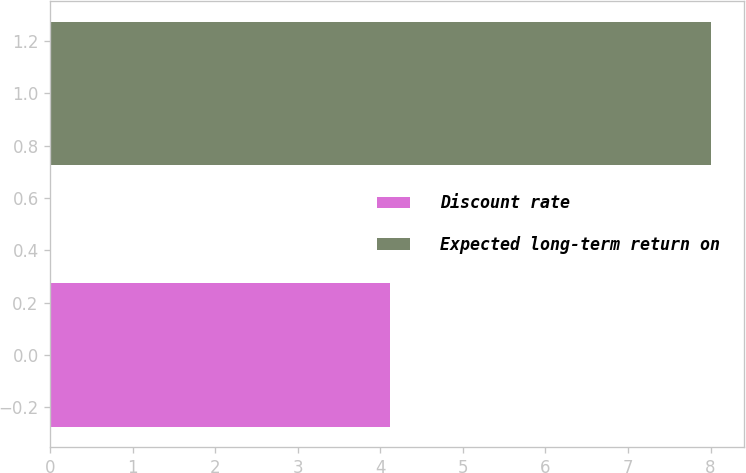Convert chart. <chart><loc_0><loc_0><loc_500><loc_500><bar_chart><fcel>Discount rate<fcel>Expected long-term return on<nl><fcel>4.12<fcel>8<nl></chart> 